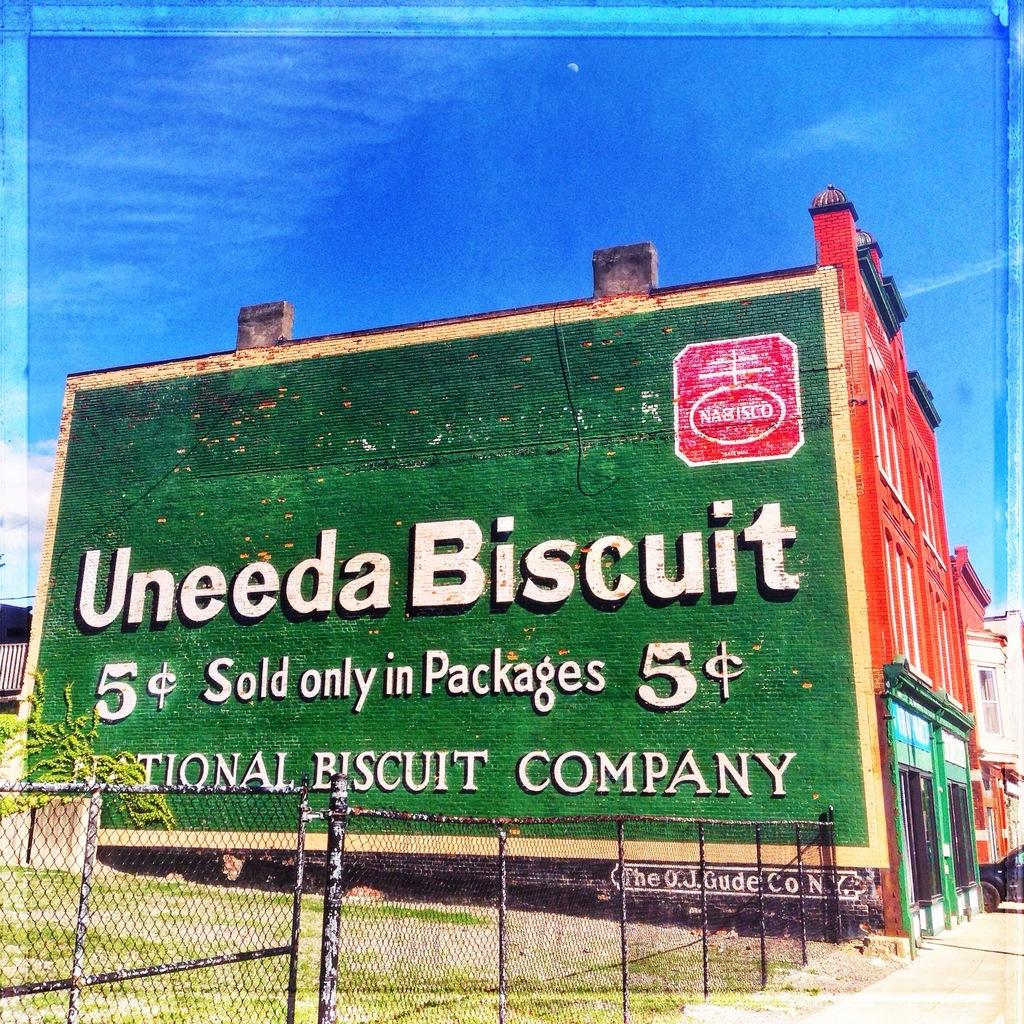<image>
Present a compact description of the photo's key features. At some point in time when you could get a Nabisco biscuit for 5 cents. 